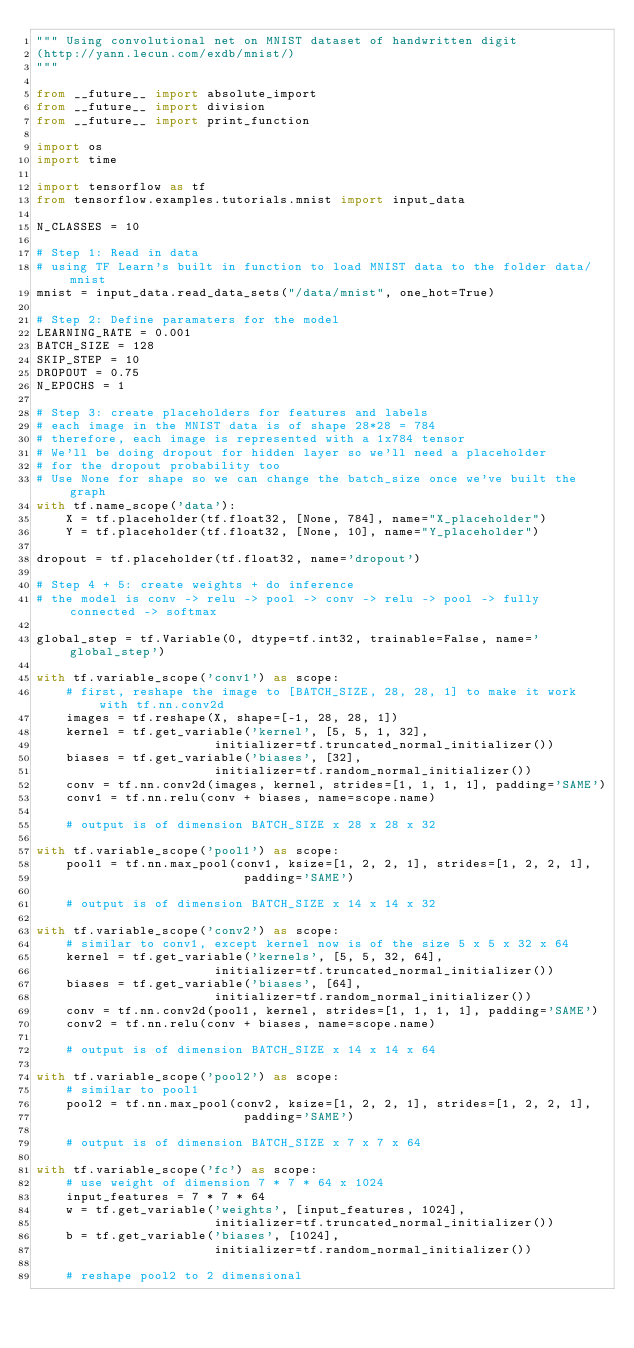<code> <loc_0><loc_0><loc_500><loc_500><_Python_>""" Using convolutional net on MNIST dataset of handwritten digit
(http://yann.lecun.com/exdb/mnist/)
"""

from __future__ import absolute_import
from __future__ import division
from __future__ import print_function

import os
import time 

import tensorflow as tf
from tensorflow.examples.tutorials.mnist import input_data

N_CLASSES = 10

# Step 1: Read in data
# using TF Learn's built in function to load MNIST data to the folder data/mnist
mnist = input_data.read_data_sets("/data/mnist", one_hot=True)

# Step 2: Define paramaters for the model
LEARNING_RATE = 0.001
BATCH_SIZE = 128
SKIP_STEP = 10
DROPOUT = 0.75
N_EPOCHS = 1

# Step 3: create placeholders for features and labels
# each image in the MNIST data is of shape 28*28 = 784
# therefore, each image is represented with a 1x784 tensor
# We'll be doing dropout for hidden layer so we'll need a placeholder
# for the dropout probability too
# Use None for shape so we can change the batch_size once we've built the graph
with tf.name_scope('data'):
    X = tf.placeholder(tf.float32, [None, 784], name="X_placeholder")
    Y = tf.placeholder(tf.float32, [None, 10], name="Y_placeholder")

dropout = tf.placeholder(tf.float32, name='dropout')

# Step 4 + 5: create weights + do inference
# the model is conv -> relu -> pool -> conv -> relu -> pool -> fully connected -> softmax

global_step = tf.Variable(0, dtype=tf.int32, trainable=False, name='global_step')

with tf.variable_scope('conv1') as scope:
    # first, reshape the image to [BATCH_SIZE, 28, 28, 1] to make it work with tf.nn.conv2d
    images = tf.reshape(X, shape=[-1, 28, 28, 1]) 
    kernel = tf.get_variable('kernel', [5, 5, 1, 32], 
                        initializer=tf.truncated_normal_initializer())
    biases = tf.get_variable('biases', [32],
                        initializer=tf.random_normal_initializer())
    conv = tf.nn.conv2d(images, kernel, strides=[1, 1, 1, 1], padding='SAME')
    conv1 = tf.nn.relu(conv + biases, name=scope.name)

    # output is of dimension BATCH_SIZE x 28 x 28 x 32

with tf.variable_scope('pool1') as scope:
    pool1 = tf.nn.max_pool(conv1, ksize=[1, 2, 2, 1], strides=[1, 2, 2, 1],
                            padding='SAME')

    # output is of dimension BATCH_SIZE x 14 x 14 x 32

with tf.variable_scope('conv2') as scope:
    # similar to conv1, except kernel now is of the size 5 x 5 x 32 x 64
    kernel = tf.get_variable('kernels', [5, 5, 32, 64], 
                        initializer=tf.truncated_normal_initializer())
    biases = tf.get_variable('biases', [64],
                        initializer=tf.random_normal_initializer())
    conv = tf.nn.conv2d(pool1, kernel, strides=[1, 1, 1, 1], padding='SAME')
    conv2 = tf.nn.relu(conv + biases, name=scope.name)

    # output is of dimension BATCH_SIZE x 14 x 14 x 64

with tf.variable_scope('pool2') as scope:
    # similar to pool1
    pool2 = tf.nn.max_pool(conv2, ksize=[1, 2, 2, 1], strides=[1, 2, 2, 1],
                            padding='SAME')

    # output is of dimension BATCH_SIZE x 7 x 7 x 64

with tf.variable_scope('fc') as scope:
    # use weight of dimension 7 * 7 * 64 x 1024
    input_features = 7 * 7 * 64
    w = tf.get_variable('weights', [input_features, 1024],
                        initializer=tf.truncated_normal_initializer())
    b = tf.get_variable('biases', [1024],
                        initializer=tf.random_normal_initializer())

    # reshape pool2 to 2 dimensional</code> 